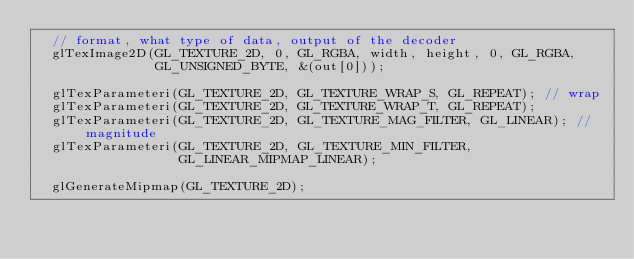<code> <loc_0><loc_0><loc_500><loc_500><_C++_>  // format, what type of data, output of the decoder
  glTexImage2D(GL_TEXTURE_2D, 0, GL_RGBA, width, height, 0, GL_RGBA,
               GL_UNSIGNED_BYTE, &(out[0]));

  glTexParameteri(GL_TEXTURE_2D, GL_TEXTURE_WRAP_S, GL_REPEAT); // wrap
  glTexParameteri(GL_TEXTURE_2D, GL_TEXTURE_WRAP_T, GL_REPEAT);
  glTexParameteri(GL_TEXTURE_2D, GL_TEXTURE_MAG_FILTER, GL_LINEAR); // magnitude
  glTexParameteri(GL_TEXTURE_2D, GL_TEXTURE_MIN_FILTER,
                  GL_LINEAR_MIPMAP_LINEAR);

  glGenerateMipmap(GL_TEXTURE_2D);
</code> 